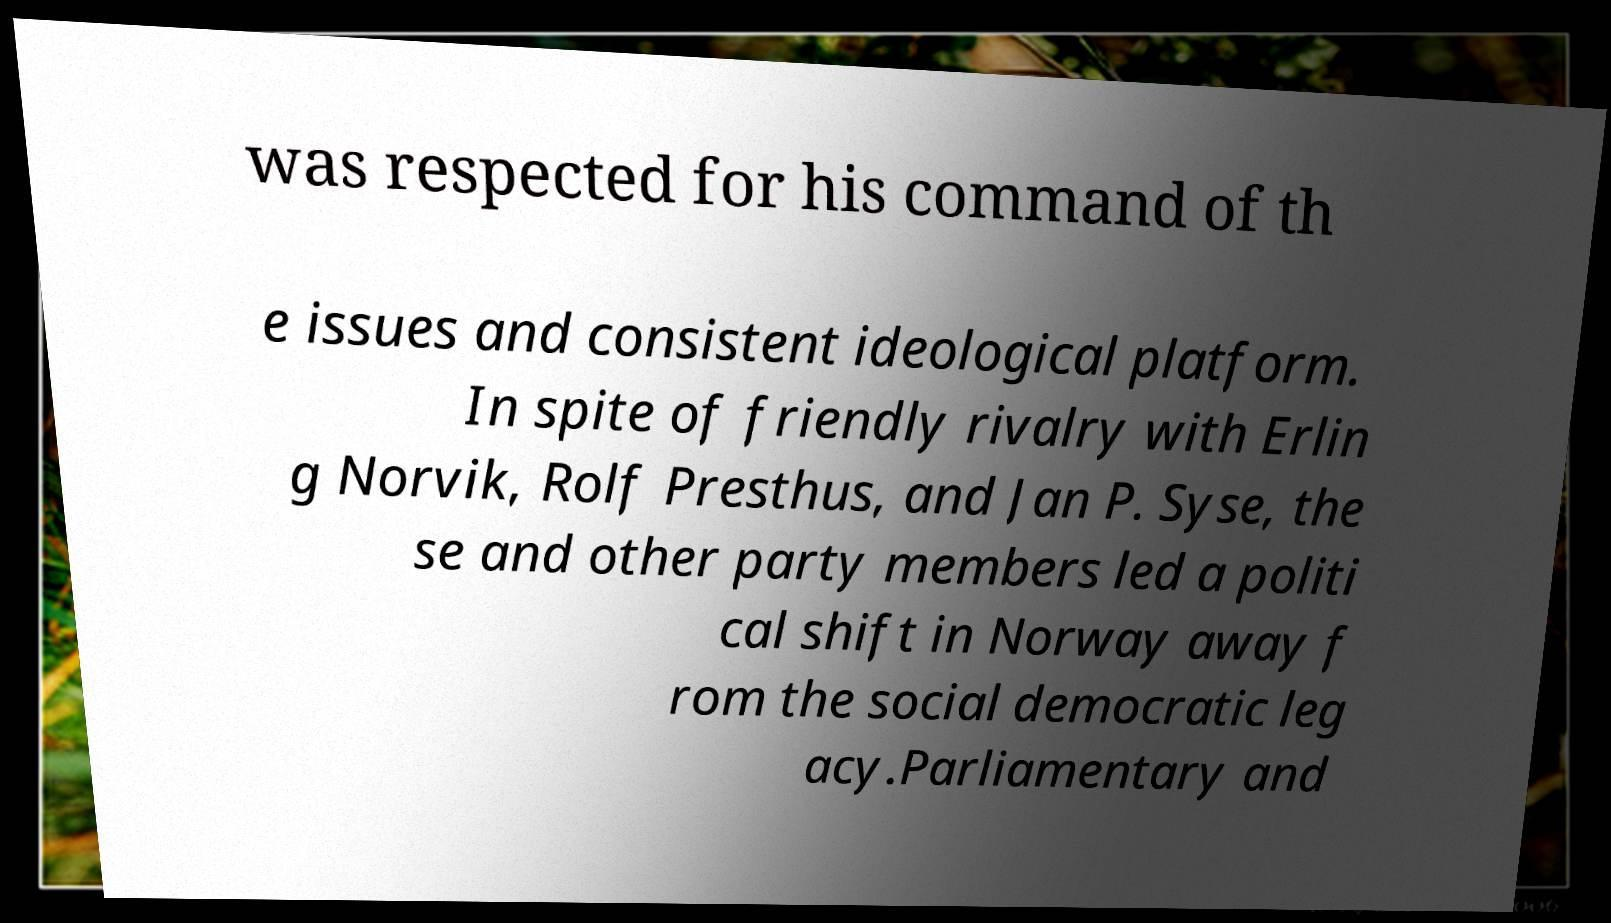Please read and relay the text visible in this image. What does it say? was respected for his command of th e issues and consistent ideological platform. In spite of friendly rivalry with Erlin g Norvik, Rolf Presthus, and Jan P. Syse, the se and other party members led a politi cal shift in Norway away f rom the social democratic leg acy.Parliamentary and 